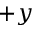Convert formula to latex. <formula><loc_0><loc_0><loc_500><loc_500>+ y</formula> 